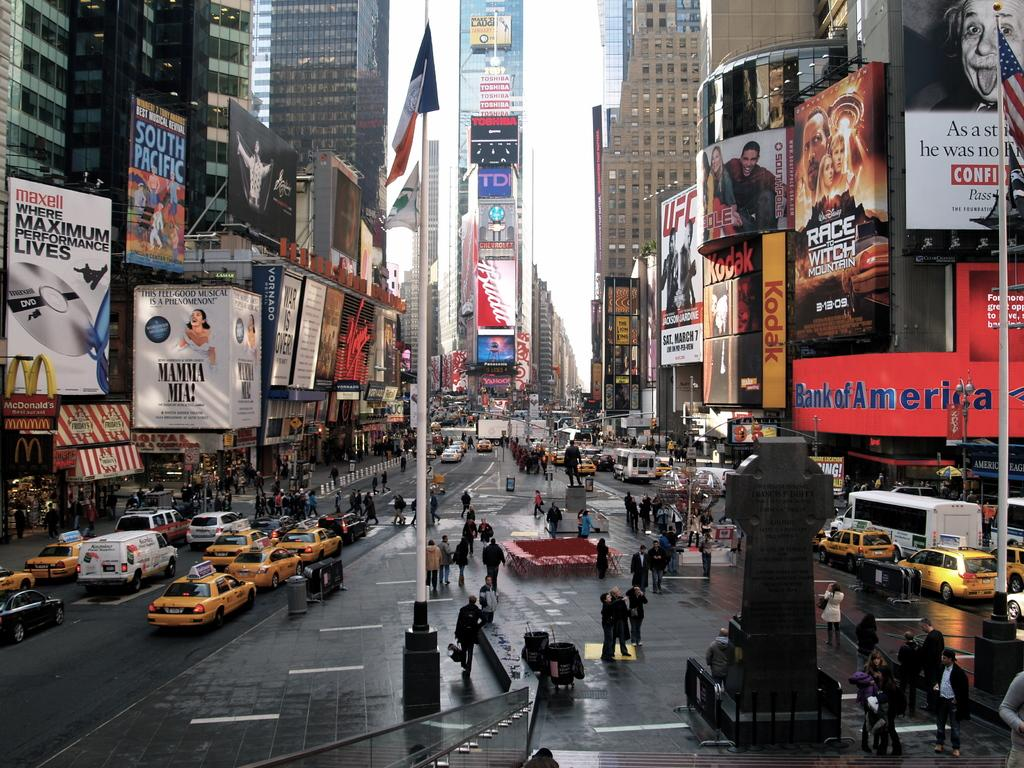<image>
Present a compact description of the photo's key features. a city with a Bank of America store near 